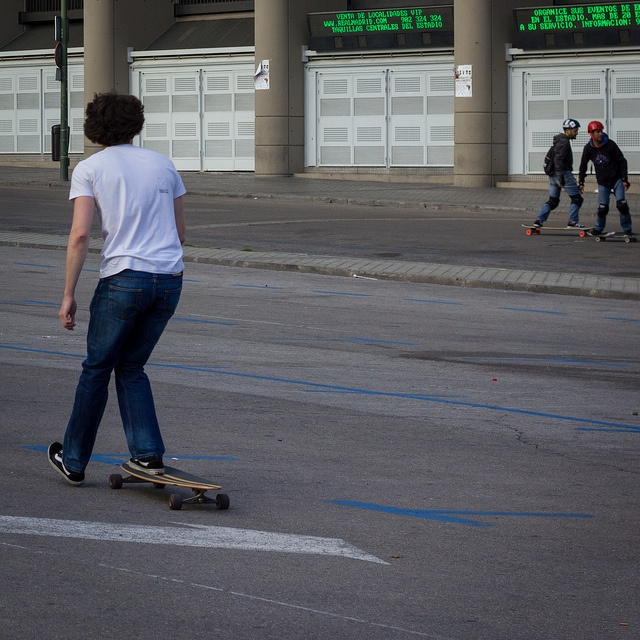Describe the objects in this image and their specific colors. I can see people in black, darkgray, gray, and navy tones, people in black, gray, navy, and maroon tones, people in black, gray, navy, and darkblue tones, skateboard in black, gray, and tan tones, and skateboard in black, gray, and maroon tones in this image. 